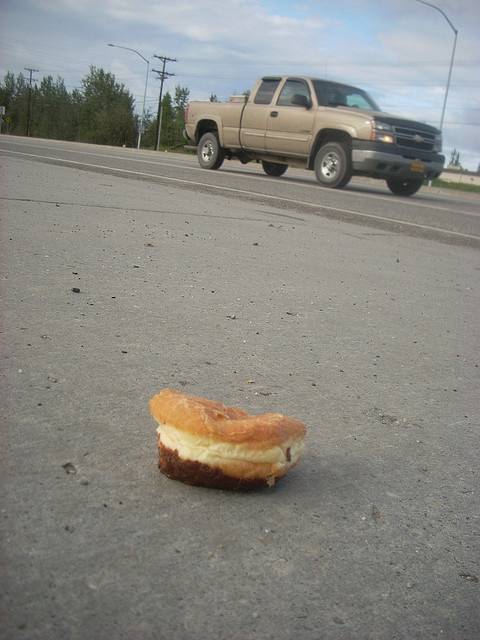Describe the objects in this image and their specific colors. I can see truck in gray, darkgray, and black tones and donut in gray, tan, and brown tones in this image. 